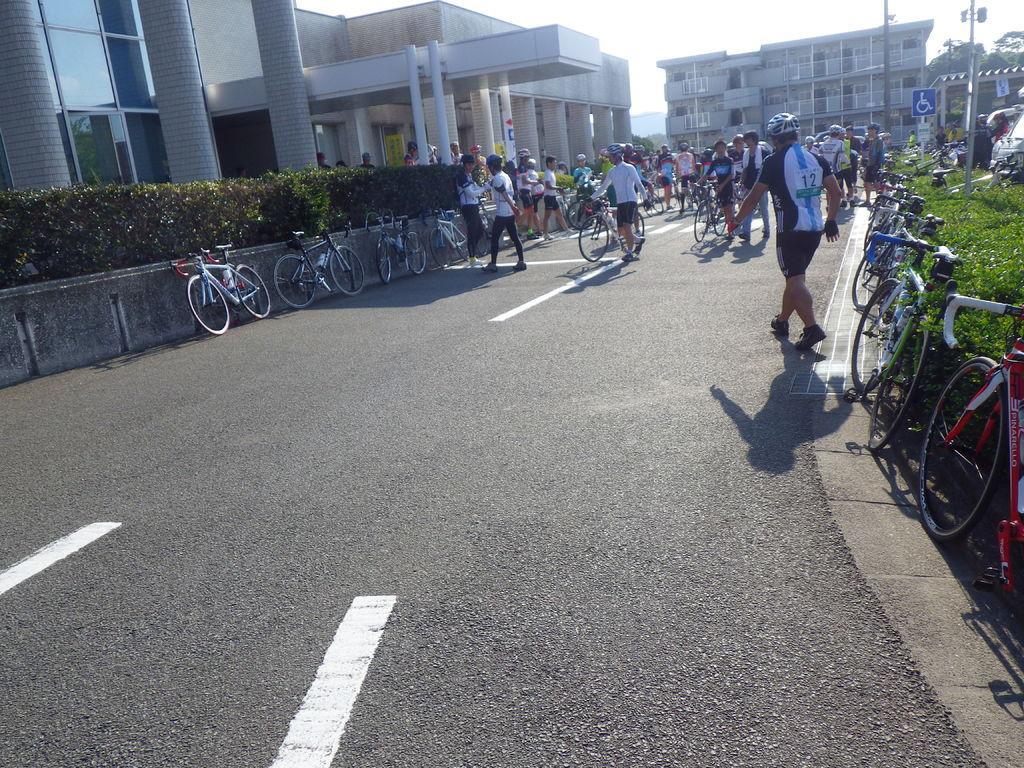How would you summarize this image in a sentence or two? In this image I can see group of people, some are standing and some are holding few bicycles. In the background I can see few vehicles, light poles, buildings, plants and trees in green color and the sky is in white color. 